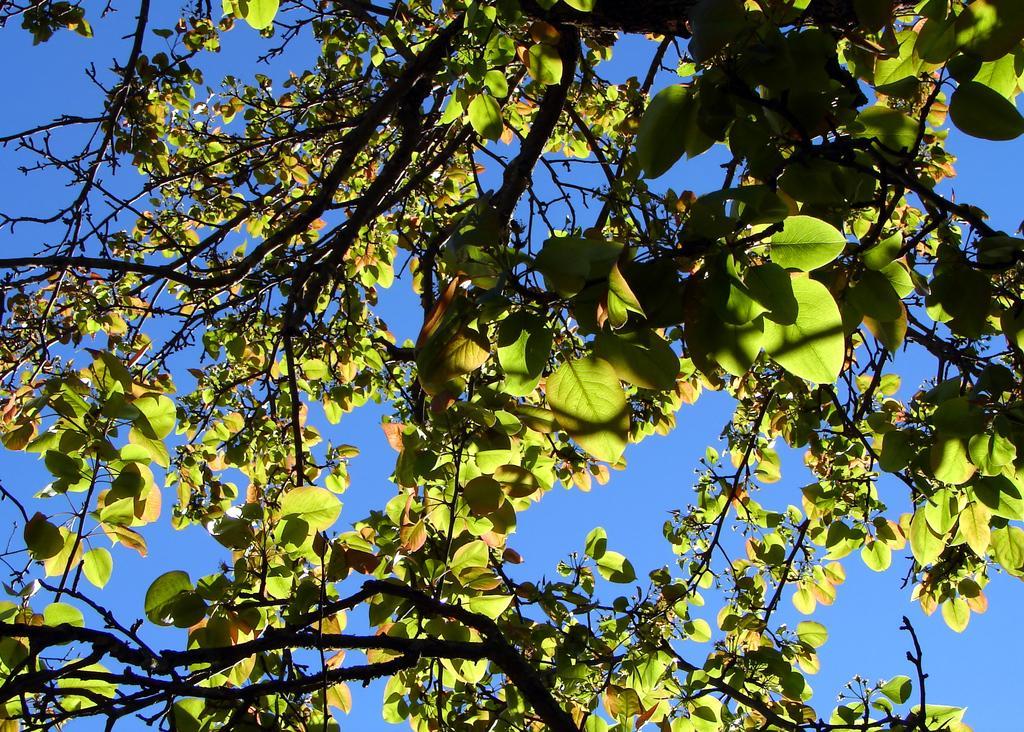Can you describe this image briefly? In the image there is a tree visible and above its sky, there is sunlight falling on the tree. 